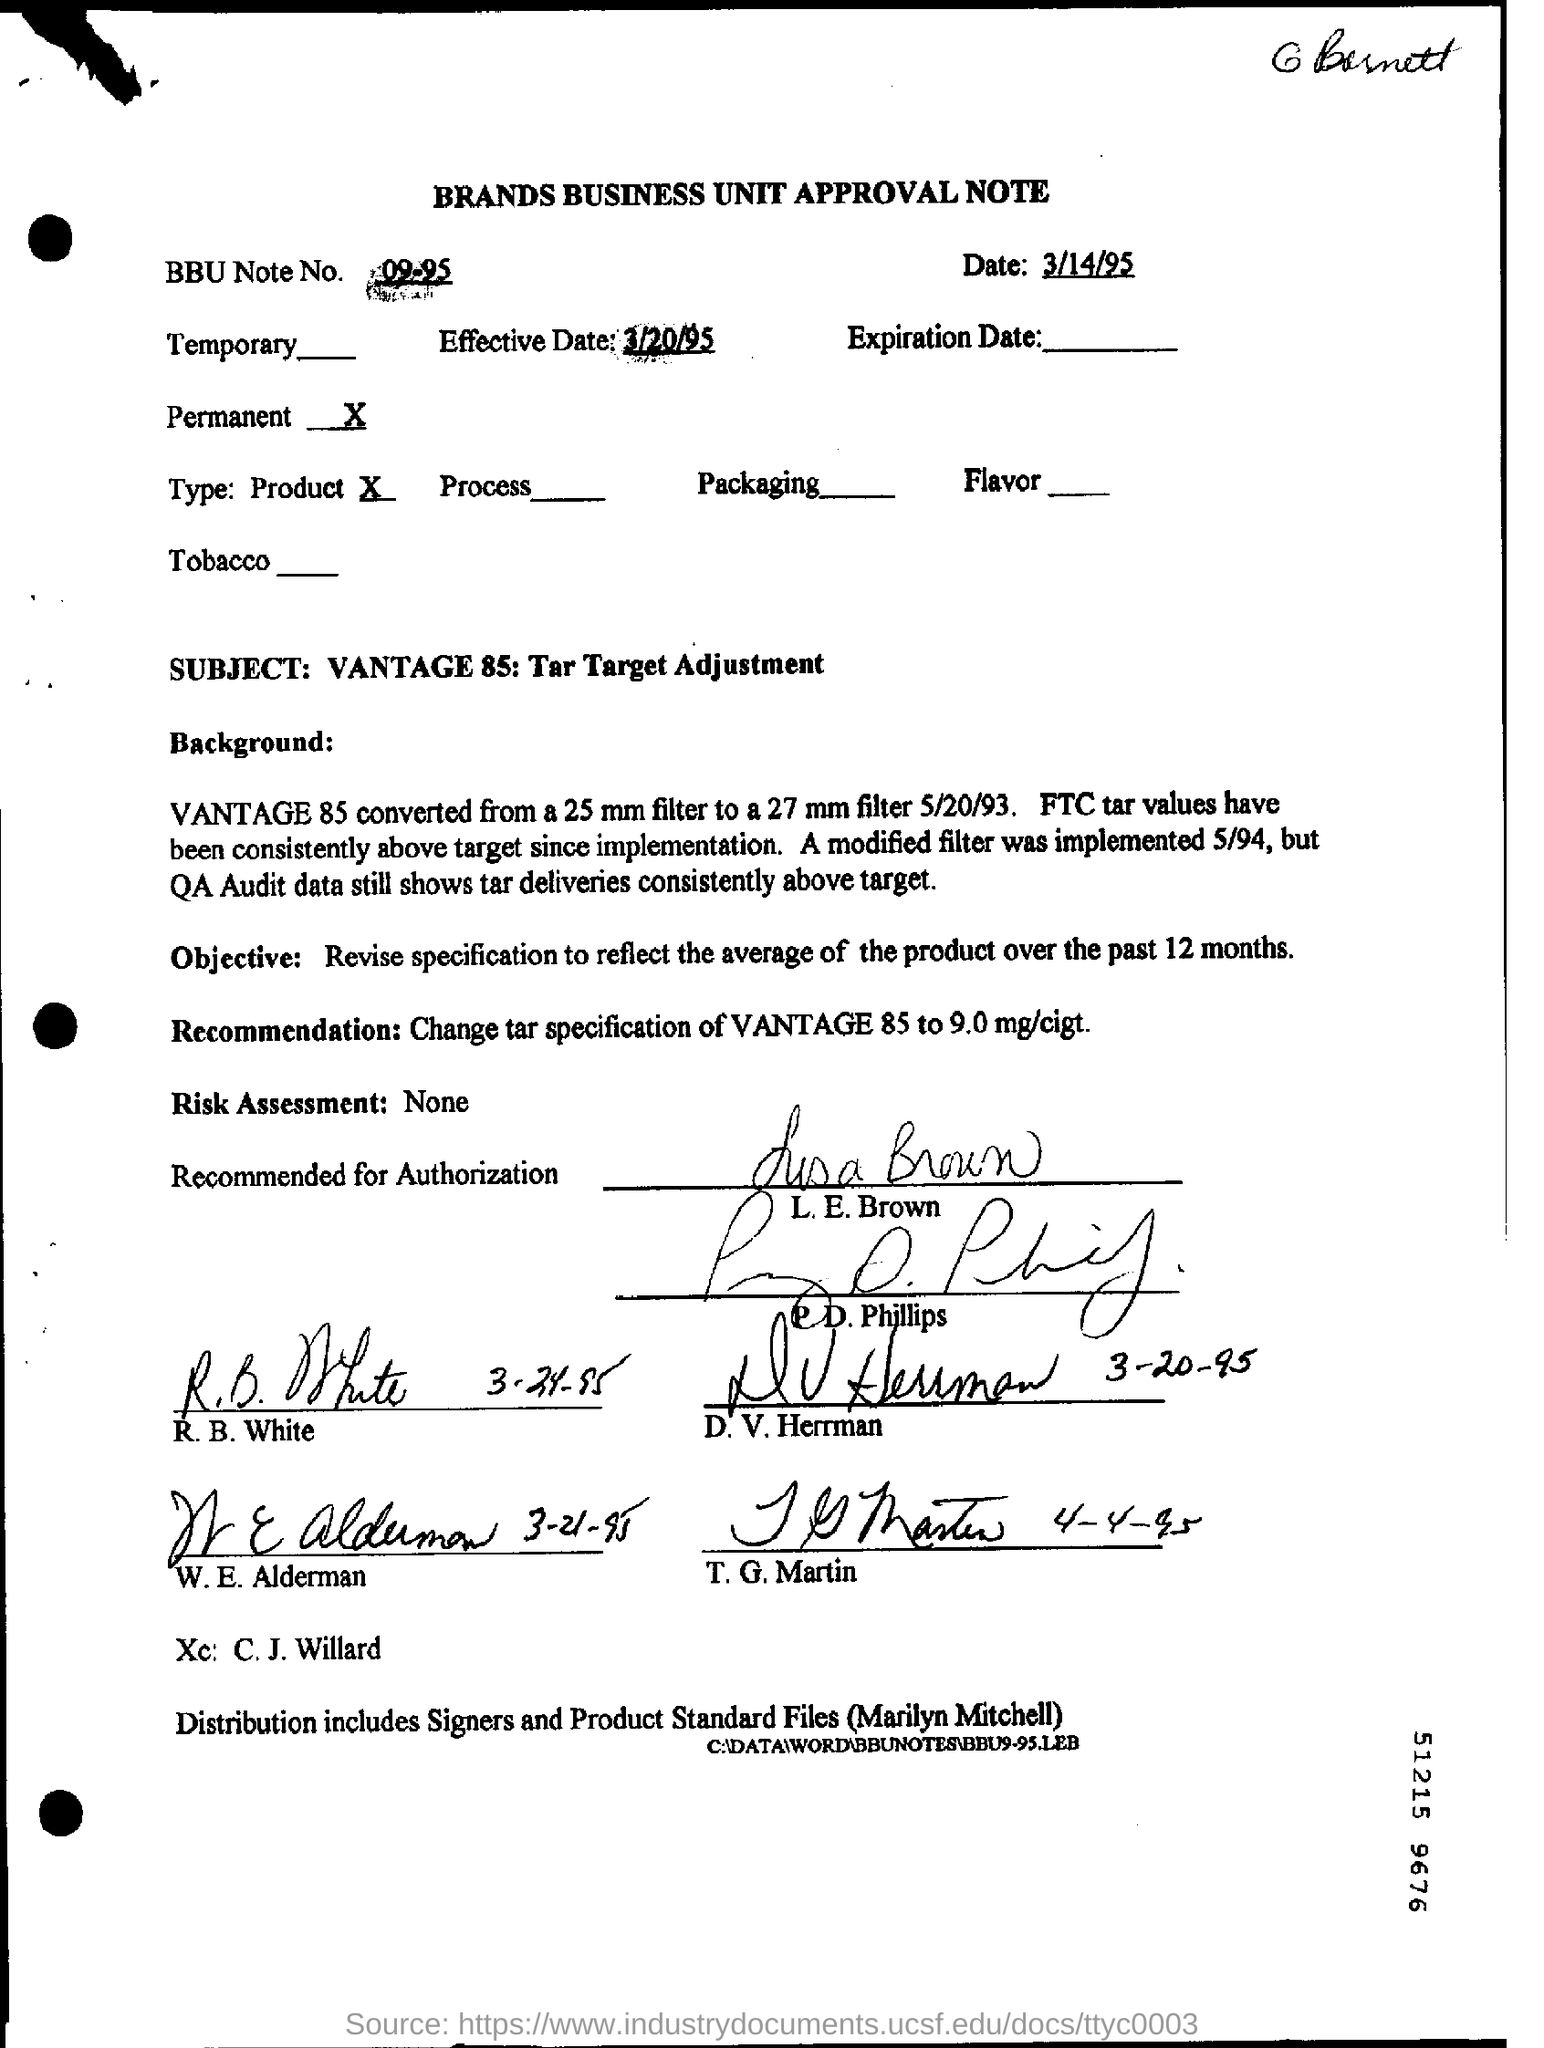What is the date mentioned in the top of the document ?
Your answer should be compact. 3/14/95. What is written in the BBU Note No Field ?
Ensure brevity in your answer.  09-95. What is written in the  Effective Date Field ?
Offer a terse response. 3/20/95. As per the form is the revision permanent or temporary?
Offer a very short reply. Permanent. 